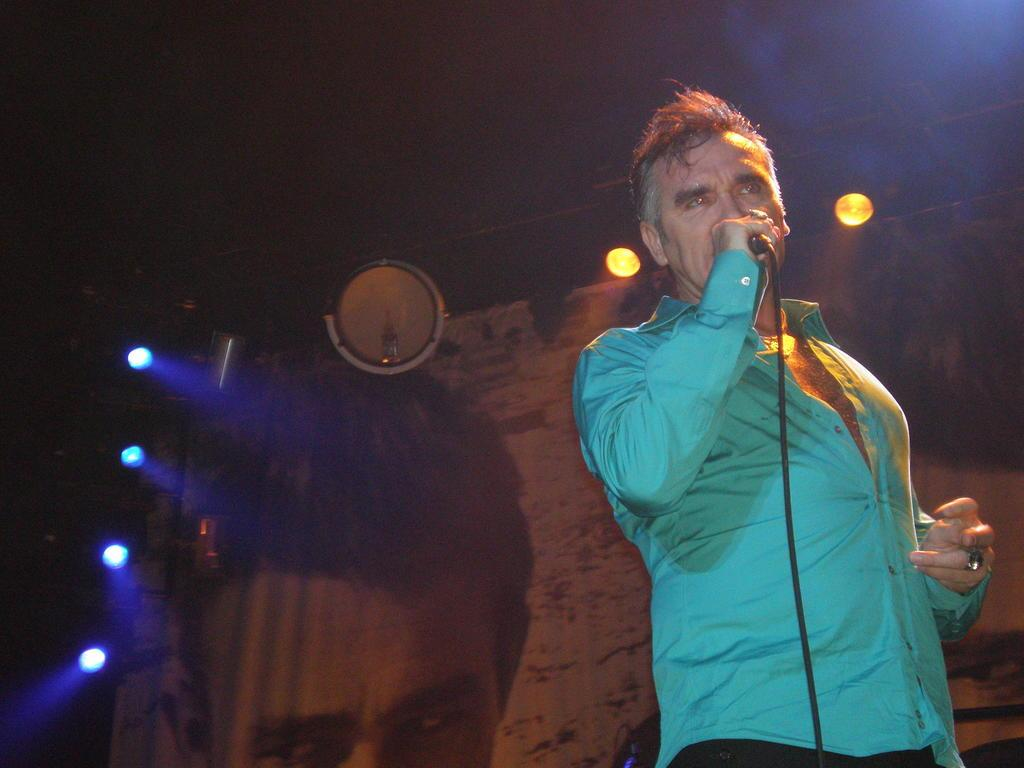What is the main subject of the image? There is a person in the image. What is the person wearing? The person is wearing a blue shirt. What is the person doing in the image? The person is standing and holding a microphone in his hand. What can be seen in the background of the image? There are lights, a banner, and a dark sky in the background of the image. How many pies are being served on the cable in the image? There are no pies or cables present in the image. What nation is represented by the banner in the image? The image does not provide enough information to determine the nation represented by the banner. 